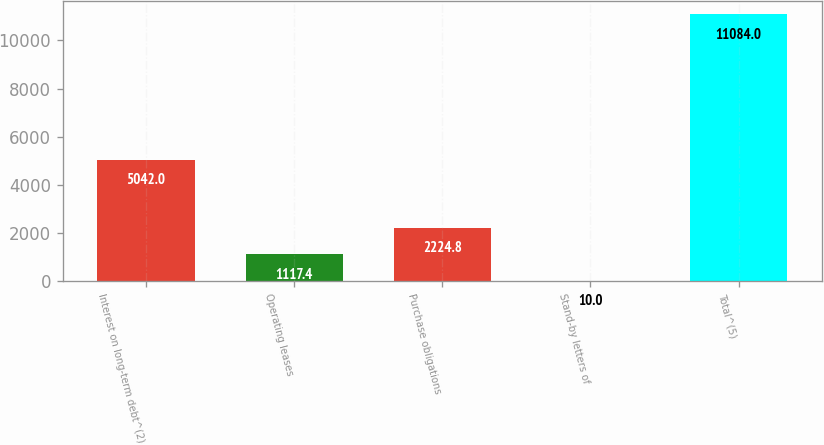Convert chart. <chart><loc_0><loc_0><loc_500><loc_500><bar_chart><fcel>Interest on long-term debt^(2)<fcel>Operating leases<fcel>Purchase obligations<fcel>Stand-by letters of<fcel>Total^(5)<nl><fcel>5042<fcel>1117.4<fcel>2224.8<fcel>10<fcel>11084<nl></chart> 